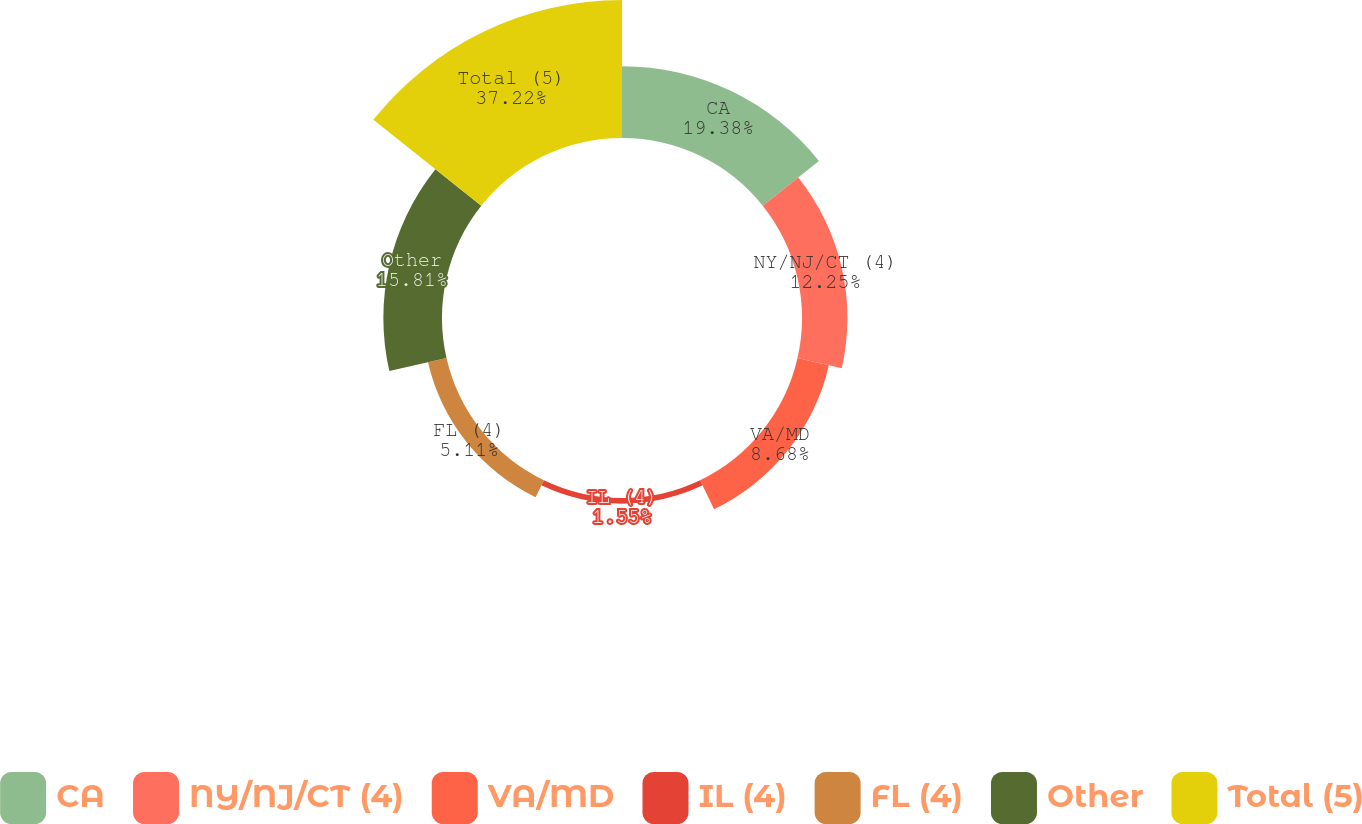Convert chart. <chart><loc_0><loc_0><loc_500><loc_500><pie_chart><fcel>CA<fcel>NY/NJ/CT (4)<fcel>VA/MD<fcel>IL (4)<fcel>FL (4)<fcel>Other<fcel>Total (5)<nl><fcel>19.38%<fcel>12.25%<fcel>8.68%<fcel>1.55%<fcel>5.11%<fcel>15.81%<fcel>37.21%<nl></chart> 